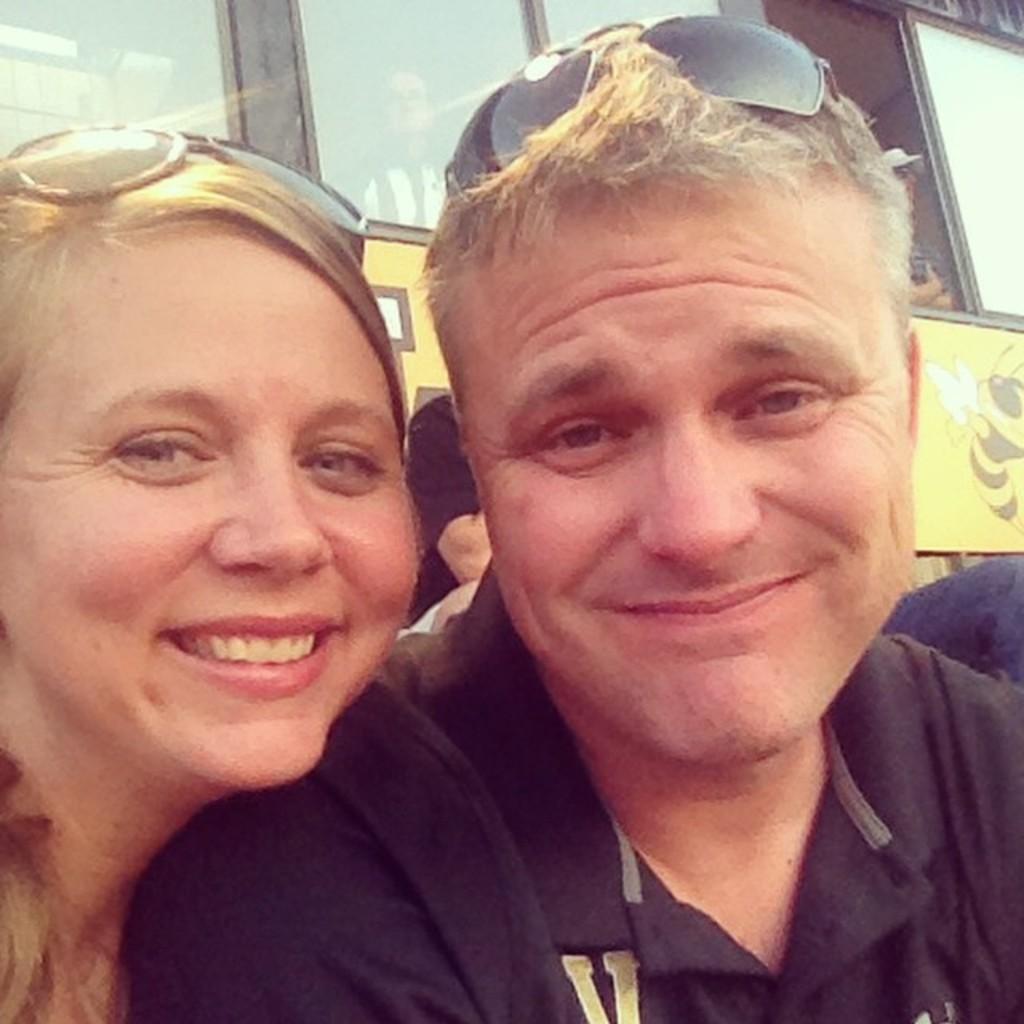Could you give a brief overview of what you see in this image? In the foreground of this picture we can see the two persons wearing goggles and smiling. In the background we can see some yellow color objects and the group of persons and some other objects. 